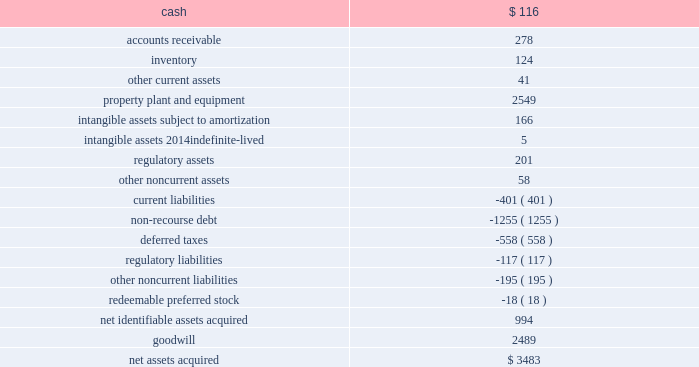The aes corporation notes to consolidated financial statements 2014 ( continued ) december 31 , 2011 , 2010 , and 2009 the preliminary allocation of the purchase price to the fair value of assets acquired and liabilities assumed is as follows ( in millions ) : .
At december 31 , 2011 , the assets acquired and liabilities assumed in the acquisition were recorded at provisional amounts based on the preliminary purchase price allocation .
The company is in the process of obtaining additional information to identify and measure all assets acquired and liabilities assumed in the acquisition within the measurement period , which could be up to one year from the date of acquisition .
Such provisional amounts will be retrospectively adjusted to reflect any new information about facts and circumstances that existed at the acquisition date that , if known , would have affected the measurement of these amounts .
Additionally , key input assumptions and their sensitivity to the valuation of assets acquired and liabilities assumed are currently being reviewed by management .
It is likely that the value of the generation business related property , plant and equipment , the intangible asset related to the electric security plan with its regulated customers and long-term coal contracts , the 4.9% ( 4.9 % ) equity ownership interest in the ohio valley electric corporation , and deferred taxes could change as the valuation process is finalized .
Dpler , dpl 2019s wholly-owned competitive retail electric service ( 201ccres 201d ) provider , will also likely have changes in its initial purchase price allocation for the valuation of its intangible assets for the trade name , and customer relationships and contracts .
As noted in the table above , the preliminary purchase price allocation has resulted in the recognition of $ 2.5 billion of goodwill .
Factors primarily contributing to a price in excess of the fair value of the net tangible and intangible assets include , but are not limited to : the ability to expand the u.s .
Utility platform in the mid-west market , the ability to capitalize on utility management experience gained from ipl , enhanced ability to negotiate with suppliers of fuel and energy , the ability to capture value associated with aes 2019 u.s .
Tax position , a well- positioned generating fleet , the ability of dpl to leverage its assembled workforce to take advantage of growth opportunities , etc .
Our ability to realize the benefit of dpl 2019s goodwill depends on the realization of expected benefits resulting from a successful integration of dpl into aes 2019 existing operations and our ability to respond to the changes in the ohio utility market .
For example , utilities in ohio continue to face downward pressure on operating margins due to the evolving regulatory environment , which is moving towards a market-based competitive pricing mechanism .
At the same time , the declining energy prices are also reducing operating .
What is the total in millions of current assets acquired? 
Computations: (((116 + 278) + 124) + 41)
Answer: 559.0. 